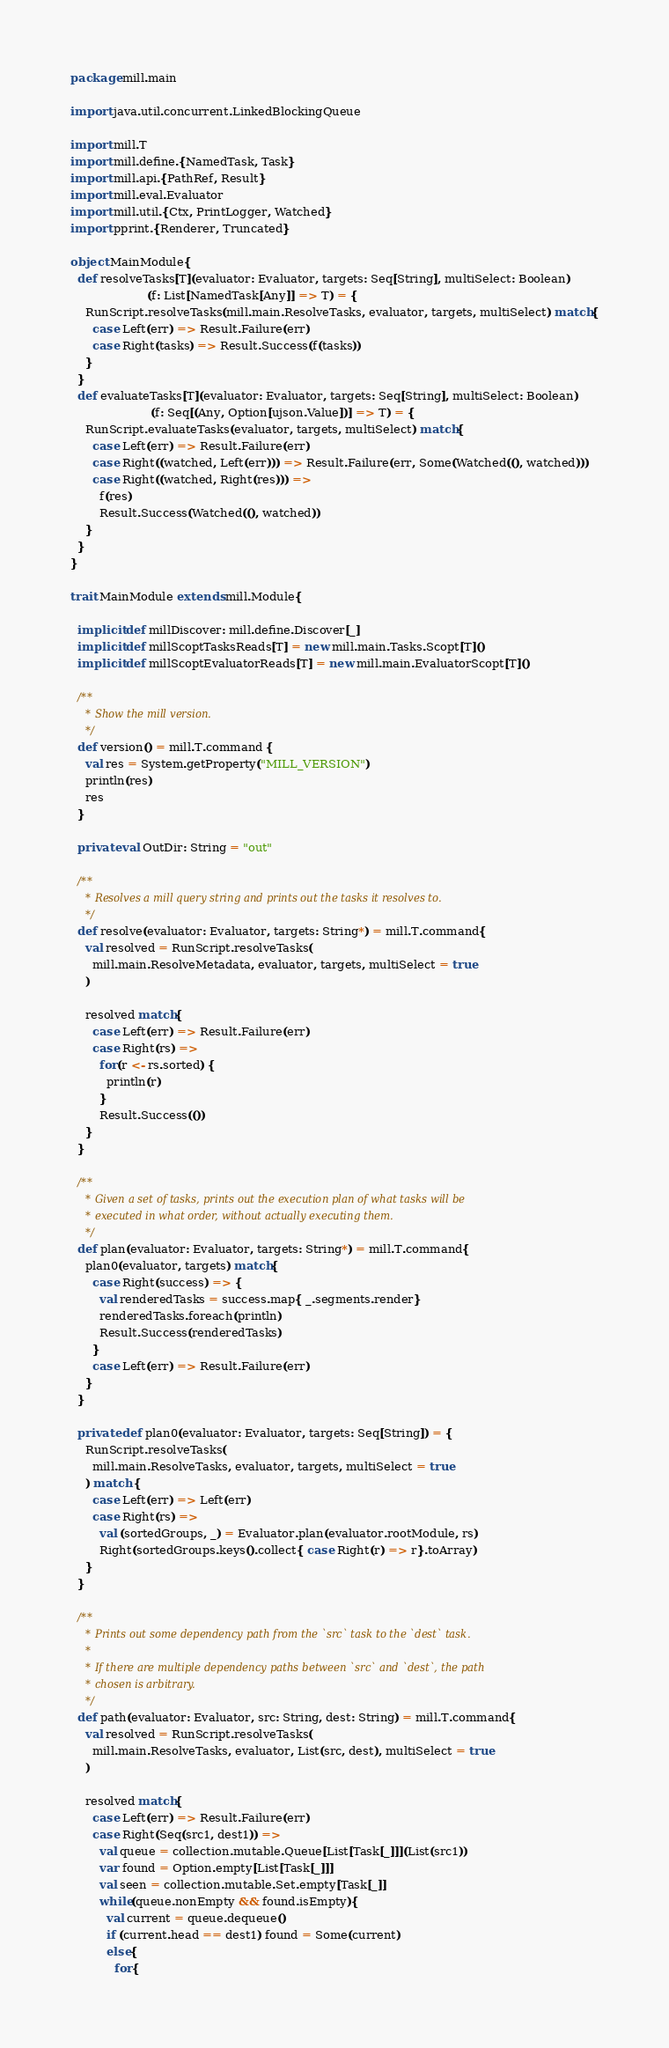<code> <loc_0><loc_0><loc_500><loc_500><_Scala_>package mill.main

import java.util.concurrent.LinkedBlockingQueue

import mill.T
import mill.define.{NamedTask, Task}
import mill.api.{PathRef, Result}
import mill.eval.Evaluator
import mill.util.{Ctx, PrintLogger, Watched}
import pprint.{Renderer, Truncated}

object MainModule{
  def resolveTasks[T](evaluator: Evaluator, targets: Seq[String], multiSelect: Boolean)
                     (f: List[NamedTask[Any]] => T) = {
    RunScript.resolveTasks(mill.main.ResolveTasks, evaluator, targets, multiSelect) match{
      case Left(err) => Result.Failure(err)
      case Right(tasks) => Result.Success(f(tasks))
    }
  }
  def evaluateTasks[T](evaluator: Evaluator, targets: Seq[String], multiSelect: Boolean)
                      (f: Seq[(Any, Option[ujson.Value])] => T) = {
    RunScript.evaluateTasks(evaluator, targets, multiSelect) match{
      case Left(err) => Result.Failure(err)
      case Right((watched, Left(err))) => Result.Failure(err, Some(Watched((), watched)))
      case Right((watched, Right(res))) =>
        f(res)
        Result.Success(Watched((), watched))
    }
  }
}

trait MainModule extends mill.Module{

  implicit def millDiscover: mill.define.Discover[_]
  implicit def millScoptTasksReads[T] = new mill.main.Tasks.Scopt[T]()
  implicit def millScoptEvaluatorReads[T] = new mill.main.EvaluatorScopt[T]()

  /**
    * Show the mill version.
    */
  def version() = mill.T.command {
    val res = System.getProperty("MILL_VERSION")
    println(res)
    res
  }

  private val OutDir: String = "out"

  /**
    * Resolves a mill query string and prints out the tasks it resolves to.
    */
  def resolve(evaluator: Evaluator, targets: String*) = mill.T.command{
    val resolved = RunScript.resolveTasks(
      mill.main.ResolveMetadata, evaluator, targets, multiSelect = true
    )

    resolved match{
      case Left(err) => Result.Failure(err)
      case Right(rs) =>
        for(r <- rs.sorted) {
          println(r)
        }
        Result.Success(())
    }
  }

  /**
    * Given a set of tasks, prints out the execution plan of what tasks will be
    * executed in what order, without actually executing them.
    */
  def plan(evaluator: Evaluator, targets: String*) = mill.T.command{
    plan0(evaluator, targets) match{
      case Right(success) => {
        val renderedTasks = success.map{ _.segments.render}
        renderedTasks.foreach(println)
        Result.Success(renderedTasks)
      }
      case Left(err) => Result.Failure(err)
    }
  }

  private def plan0(evaluator: Evaluator, targets: Seq[String]) = {
    RunScript.resolveTasks(
      mill.main.ResolveTasks, evaluator, targets, multiSelect = true
    ) match {
      case Left(err) => Left(err)
      case Right(rs) =>
        val (sortedGroups, _) = Evaluator.plan(evaluator.rootModule, rs)
        Right(sortedGroups.keys().collect{ case Right(r) => r}.toArray)
    }
  }

  /**
    * Prints out some dependency path from the `src` task to the `dest` task.
    *
    * If there are multiple dependency paths between `src` and `dest`, the path
    * chosen is arbitrary.
    */
  def path(evaluator: Evaluator, src: String, dest: String) = mill.T.command{
    val resolved = RunScript.resolveTasks(
      mill.main.ResolveTasks, evaluator, List(src, dest), multiSelect = true
    )

    resolved match{
      case Left(err) => Result.Failure(err)
      case Right(Seq(src1, dest1)) =>
        val queue = collection.mutable.Queue[List[Task[_]]](List(src1))
        var found = Option.empty[List[Task[_]]]
        val seen = collection.mutable.Set.empty[Task[_]]
        while(queue.nonEmpty && found.isEmpty){
          val current = queue.dequeue()
          if (current.head == dest1) found = Some(current)
          else{
            for{</code> 